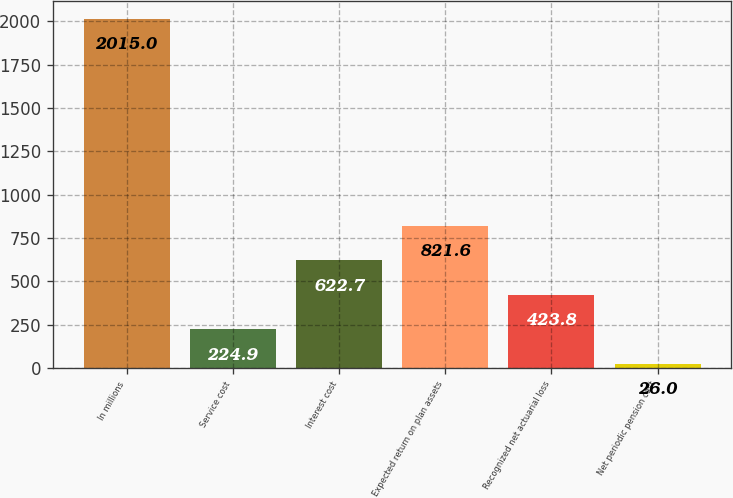Convert chart to OTSL. <chart><loc_0><loc_0><loc_500><loc_500><bar_chart><fcel>In millions<fcel>Service cost<fcel>Interest cost<fcel>Expected return on plan assets<fcel>Recognized net actuarial loss<fcel>Net periodic pension cost<nl><fcel>2015<fcel>224.9<fcel>622.7<fcel>821.6<fcel>423.8<fcel>26<nl></chart> 